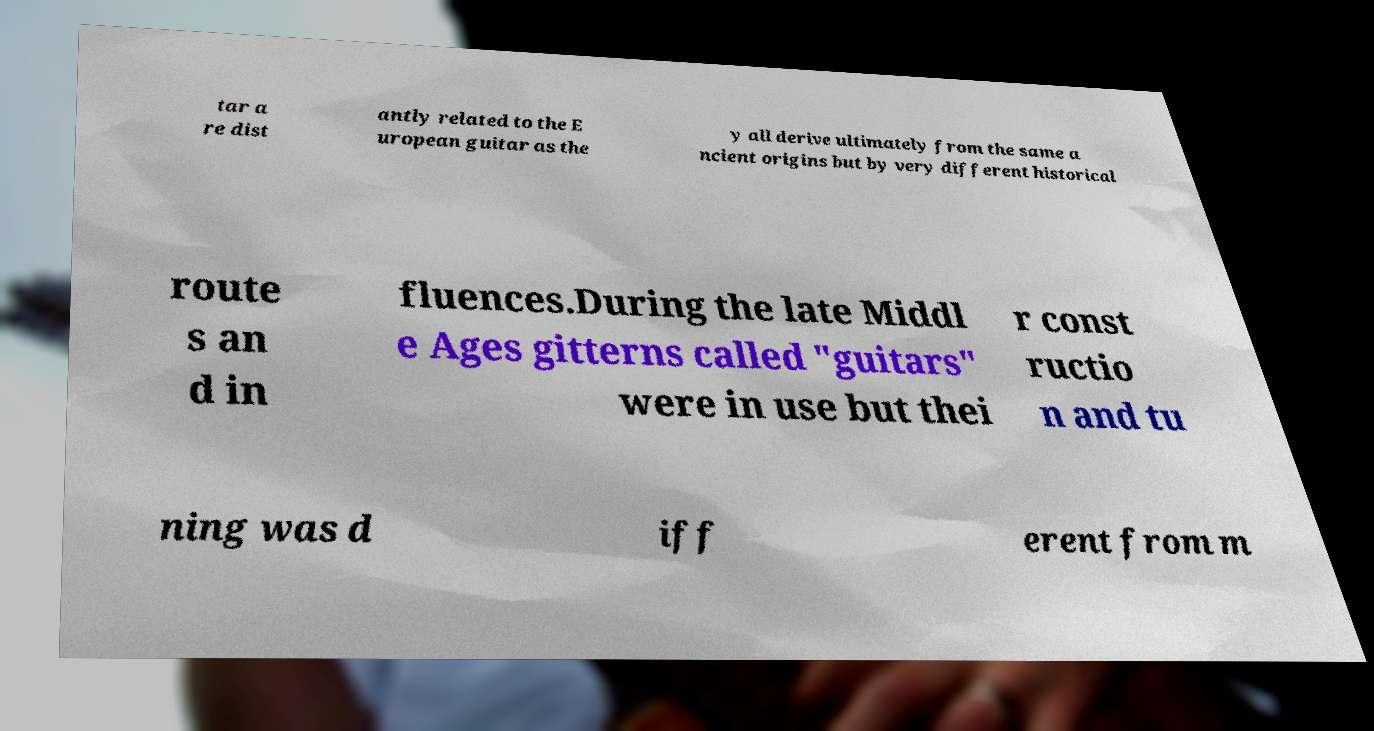What messages or text are displayed in this image? I need them in a readable, typed format. tar a re dist antly related to the E uropean guitar as the y all derive ultimately from the same a ncient origins but by very different historical route s an d in fluences.During the late Middl e Ages gitterns called "guitars" were in use but thei r const ructio n and tu ning was d iff erent from m 